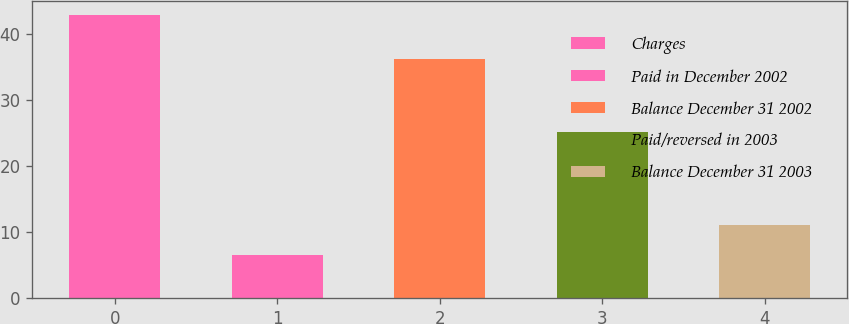Convert chart to OTSL. <chart><loc_0><loc_0><loc_500><loc_500><bar_chart><fcel>Charges<fcel>Paid in December 2002<fcel>Balance December 31 2002<fcel>Paid/reversed in 2003<fcel>Balance December 31 2003<nl><fcel>42.8<fcel>6.6<fcel>36.2<fcel>25.1<fcel>11.1<nl></chart> 